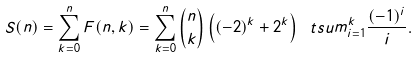Convert formula to latex. <formula><loc_0><loc_0><loc_500><loc_500>S ( n ) = \sum _ { k = 0 } ^ { n } F ( n , k ) = \sum _ { k = 0 } ^ { n } \binom { n } { k } \left ( ( - 2 ) ^ { k } + 2 ^ { k } \right ) \ t s u m _ { i = 1 } ^ { k } \frac { ( - 1 ) ^ { i } } { i } .</formula> 